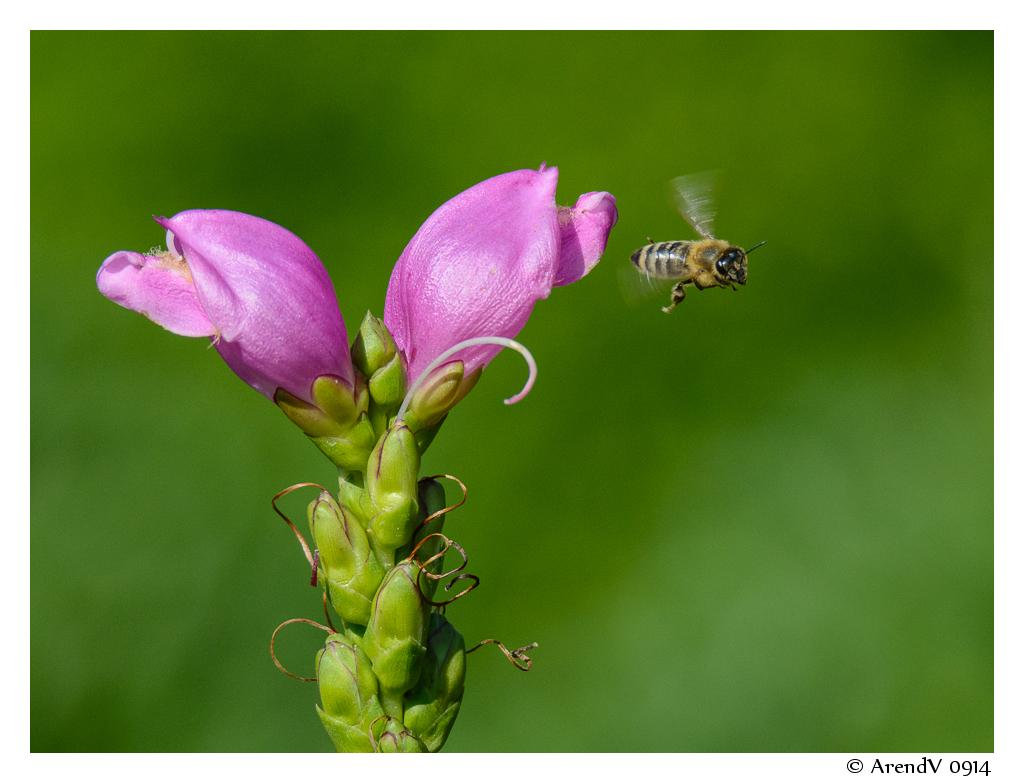What type of living organisms can be seen in the image? There are flowers and a honeybee in the image. What is the background of the image like? The background of the image is blurry. Is there any text present in the image? Yes, there is some text in the bottom right-hand corner of the image. How many houses can be seen in the image? There are no houses present in the image. What type of mountain is visible in the background of the image? There is no mountain visible in the image; the background is blurry. 